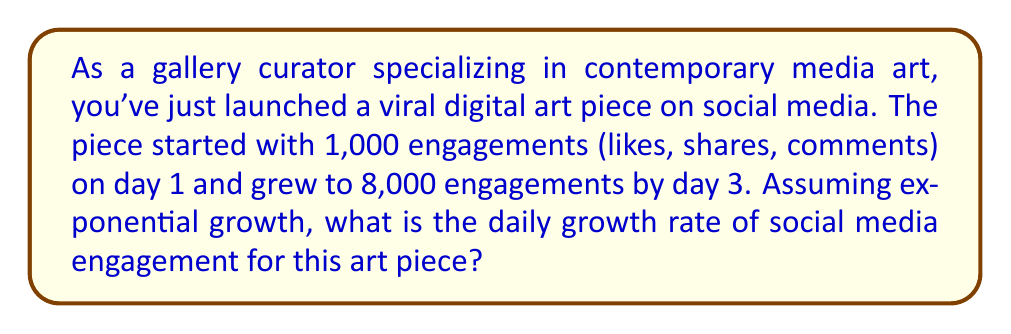Help me with this question. To solve this problem, we'll use the exponential growth formula:

$$A = P(1 + r)^t$$

Where:
$A$ = Final amount
$P$ = Initial amount
$r$ = Daily growth rate (as a decimal)
$t$ = Time period (in days)

Given:
$P = 1,000$ (initial engagements)
$A = 8,000$ (final engagements)
$t = 2$ (number of days between measurements)

Let's plug these values into the formula:

$$8,000 = 1,000(1 + r)^2$$

Now, let's solve for $r$:

1) Divide both sides by 1,000:
   $$8 = (1 + r)^2$$

2) Take the square root of both sides:
   $$\sqrt{8} = 1 + r$$

3) Simplify:
   $$2.8284 \approx 1 + r$$

4) Subtract 1 from both sides:
   $$1.8284 \approx r$$

5) Convert to a percentage:
   $$1.8284 \times 100\% \approx 182.84\%$$

Therefore, the daily growth rate is approximately 182.84%.
Answer: The daily growth rate of social media engagement for the viral art piece is approximately 182.84%. 